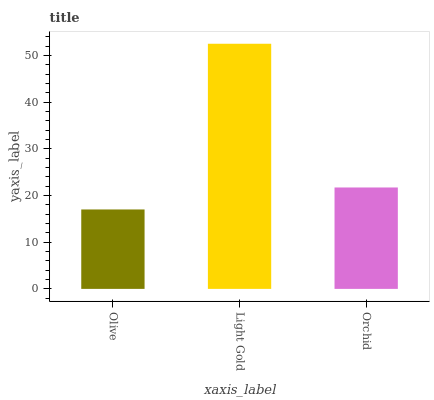Is Olive the minimum?
Answer yes or no. Yes. Is Light Gold the maximum?
Answer yes or no. Yes. Is Orchid the minimum?
Answer yes or no. No. Is Orchid the maximum?
Answer yes or no. No. Is Light Gold greater than Orchid?
Answer yes or no. Yes. Is Orchid less than Light Gold?
Answer yes or no. Yes. Is Orchid greater than Light Gold?
Answer yes or no. No. Is Light Gold less than Orchid?
Answer yes or no. No. Is Orchid the high median?
Answer yes or no. Yes. Is Orchid the low median?
Answer yes or no. Yes. Is Light Gold the high median?
Answer yes or no. No. Is Olive the low median?
Answer yes or no. No. 